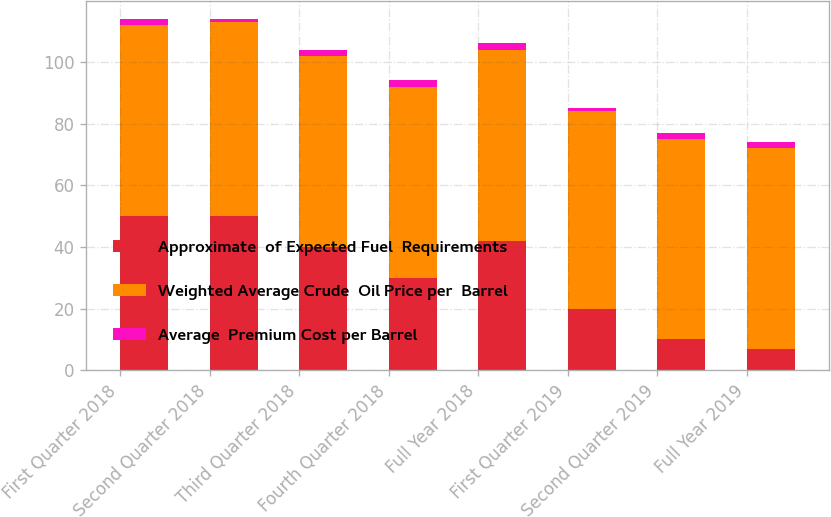Convert chart. <chart><loc_0><loc_0><loc_500><loc_500><stacked_bar_chart><ecel><fcel>First Quarter 2018<fcel>Second Quarter 2018<fcel>Third Quarter 2018<fcel>Fourth Quarter 2018<fcel>Full Year 2018<fcel>First Quarter 2019<fcel>Second Quarter 2019<fcel>Full Year 2019<nl><fcel>Approximate  of Expected Fuel  Requirements<fcel>50<fcel>50<fcel>40<fcel>30<fcel>42<fcel>20<fcel>10<fcel>7<nl><fcel>Weighted Average Crude  Oil Price per  Barrel<fcel>62<fcel>63<fcel>62<fcel>62<fcel>62<fcel>64<fcel>65<fcel>65<nl><fcel>Average  Premium Cost per Barrel<fcel>2<fcel>1<fcel>2<fcel>2<fcel>2<fcel>1<fcel>2<fcel>2<nl></chart> 